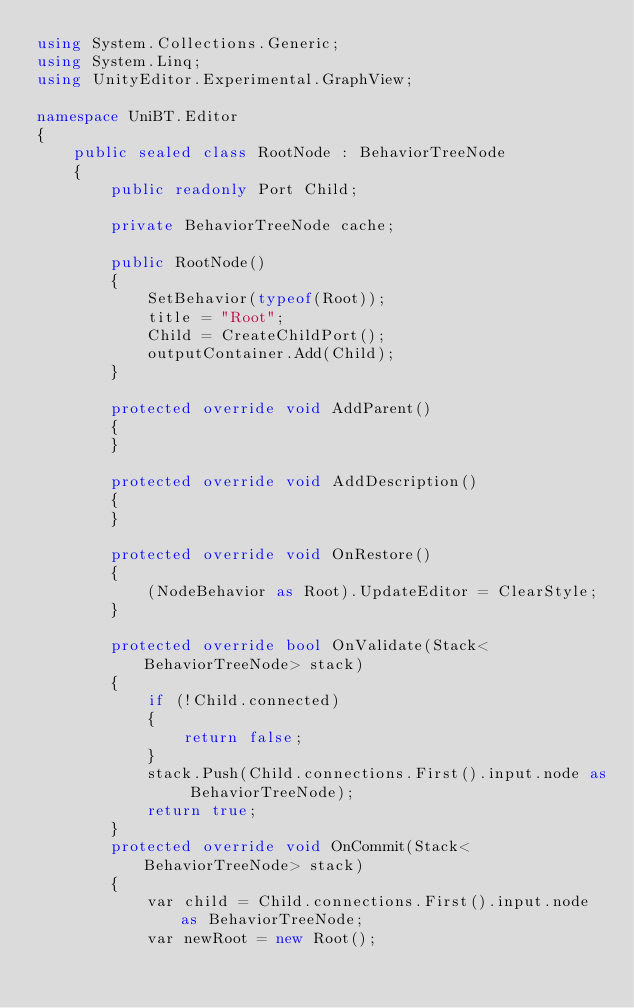Convert code to text. <code><loc_0><loc_0><loc_500><loc_500><_C#_>using System.Collections.Generic;
using System.Linq;
using UnityEditor.Experimental.GraphView;

namespace UniBT.Editor
{
    public sealed class RootNode : BehaviorTreeNode
    {
        public readonly Port Child;

        private BehaviorTreeNode cache;

        public RootNode() 
        {
            SetBehavior(typeof(Root));
            title = "Root";
            Child = CreateChildPort();
            outputContainer.Add(Child);
        }

        protected override void AddParent()
        {
        }

        protected override void AddDescription()
        {
        }

        protected override void OnRestore()
        {
            (NodeBehavior as Root).UpdateEditor = ClearStyle;
        }

        protected override bool OnValidate(Stack<BehaviorTreeNode> stack)
        {
            if (!Child.connected)
            {
                return false;
            }
            stack.Push(Child.connections.First().input.node as BehaviorTreeNode);
            return true;
        }
        protected override void OnCommit(Stack<BehaviorTreeNode> stack)
        {
            var child = Child.connections.First().input.node as BehaviorTreeNode;
            var newRoot = new Root();</code> 